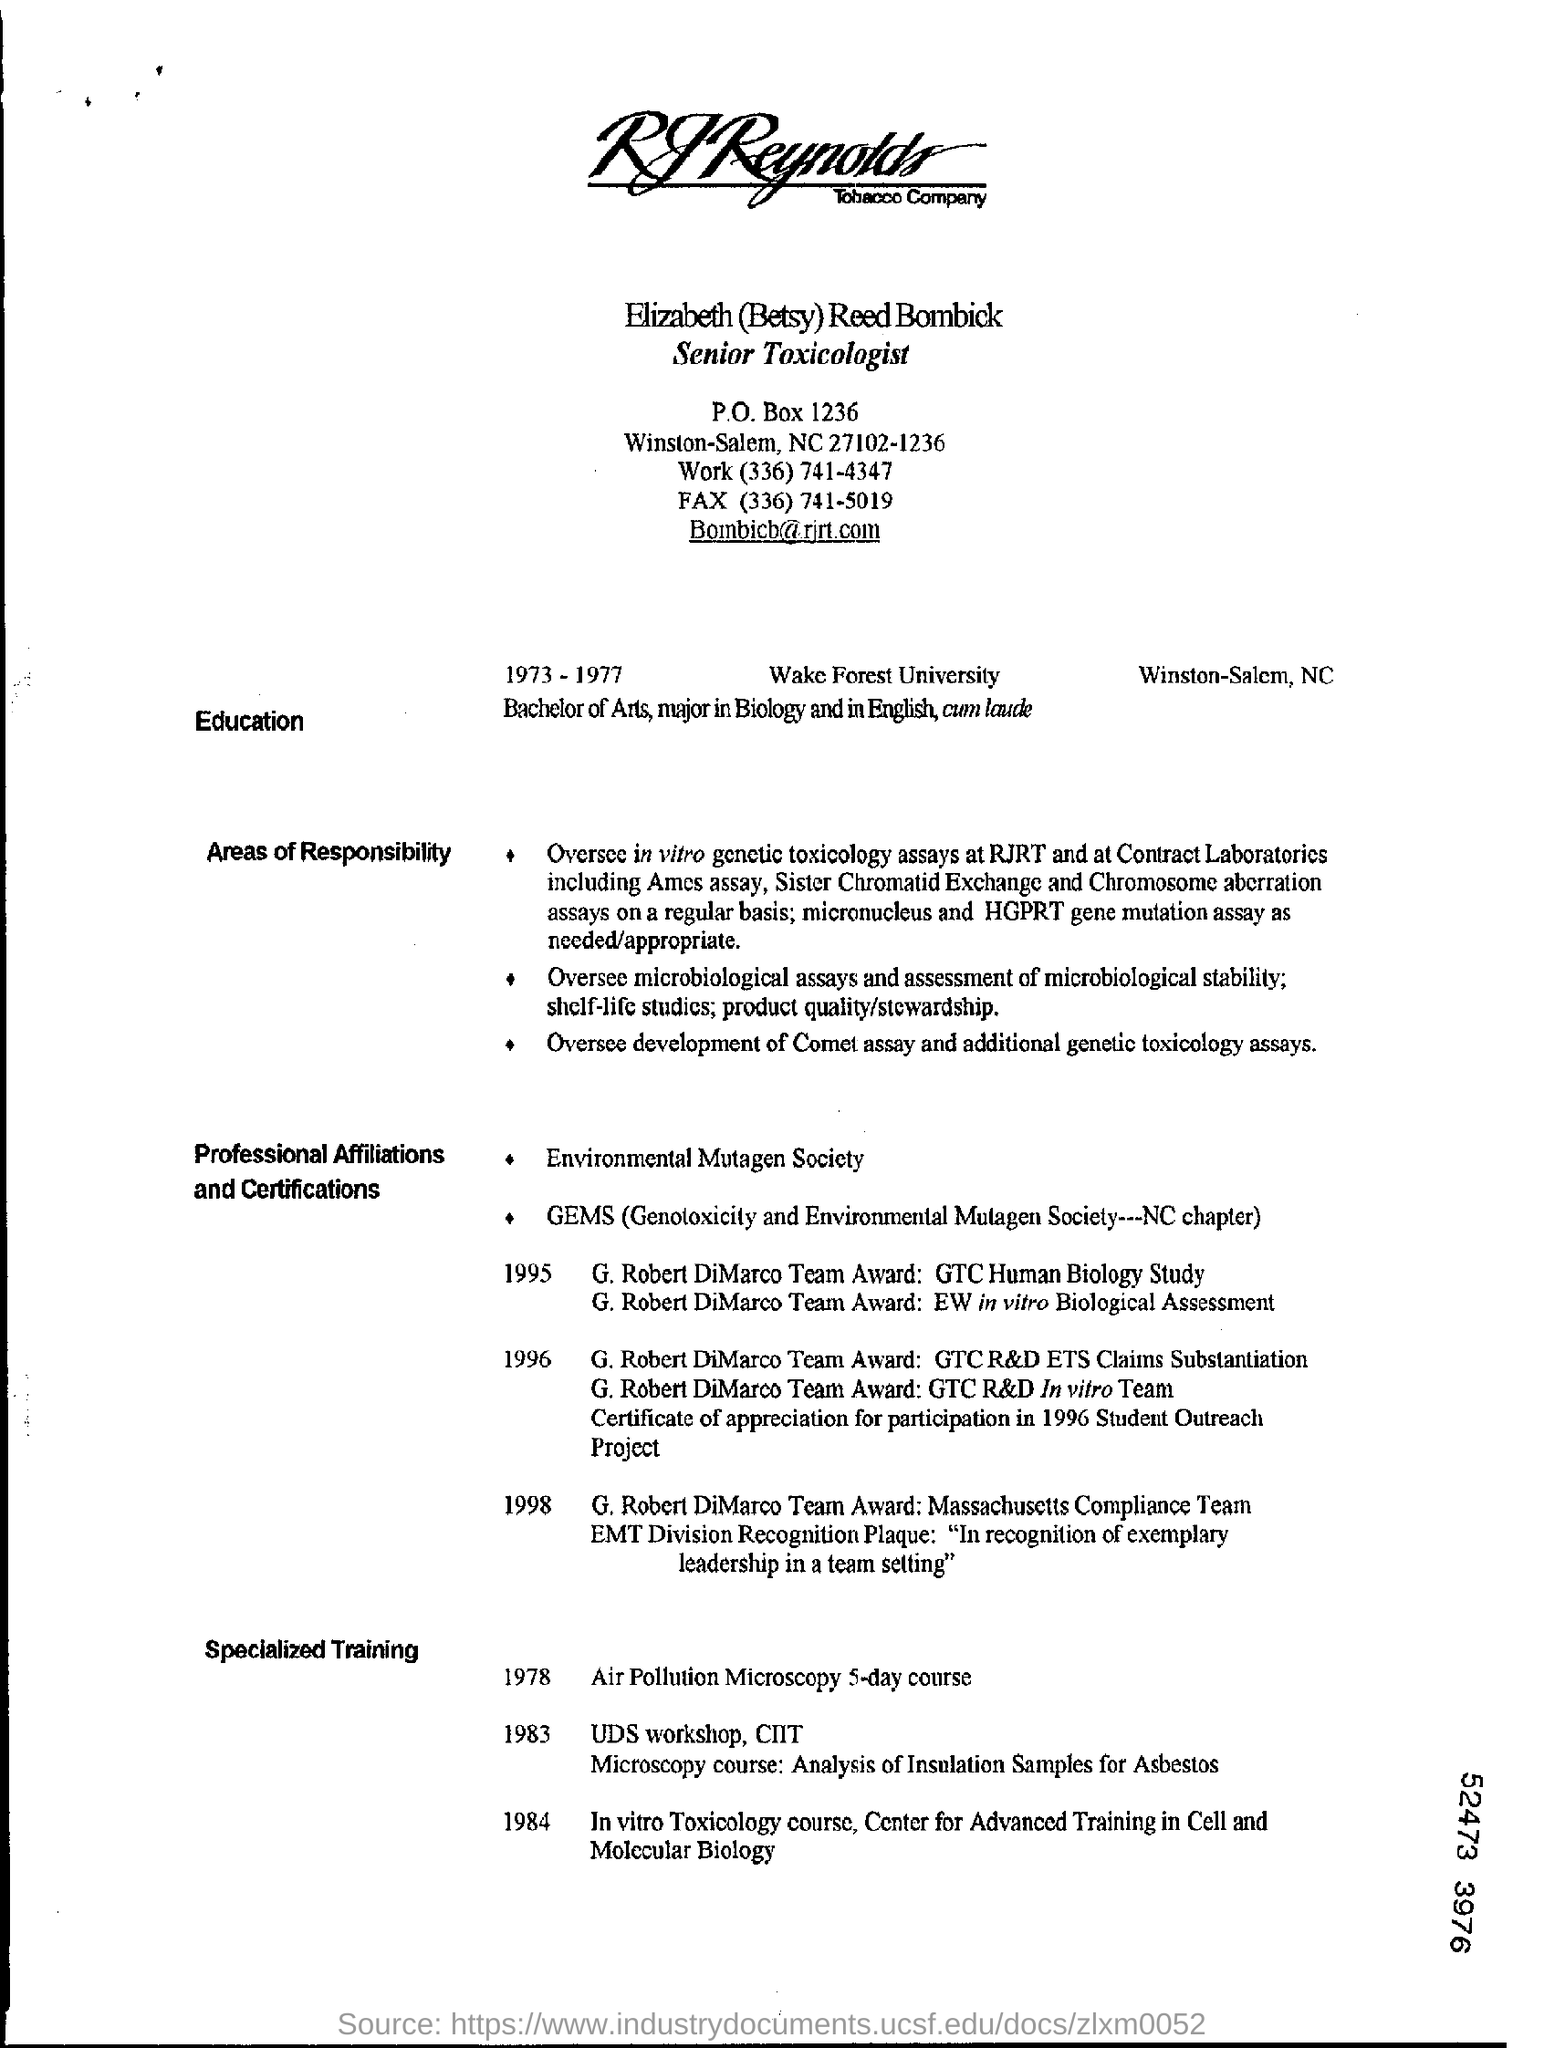Point out several critical features in this image. In 1984, Elizabeth (Betsy) Reed Bombick received specialized training in the field of in vitro toxicology. Elizabeth (Betsy) Reed Bombick received specialized training in the Air Pollution Microscopy 5-day course in 1978. The P.O.Box number mentioned is 1236. 